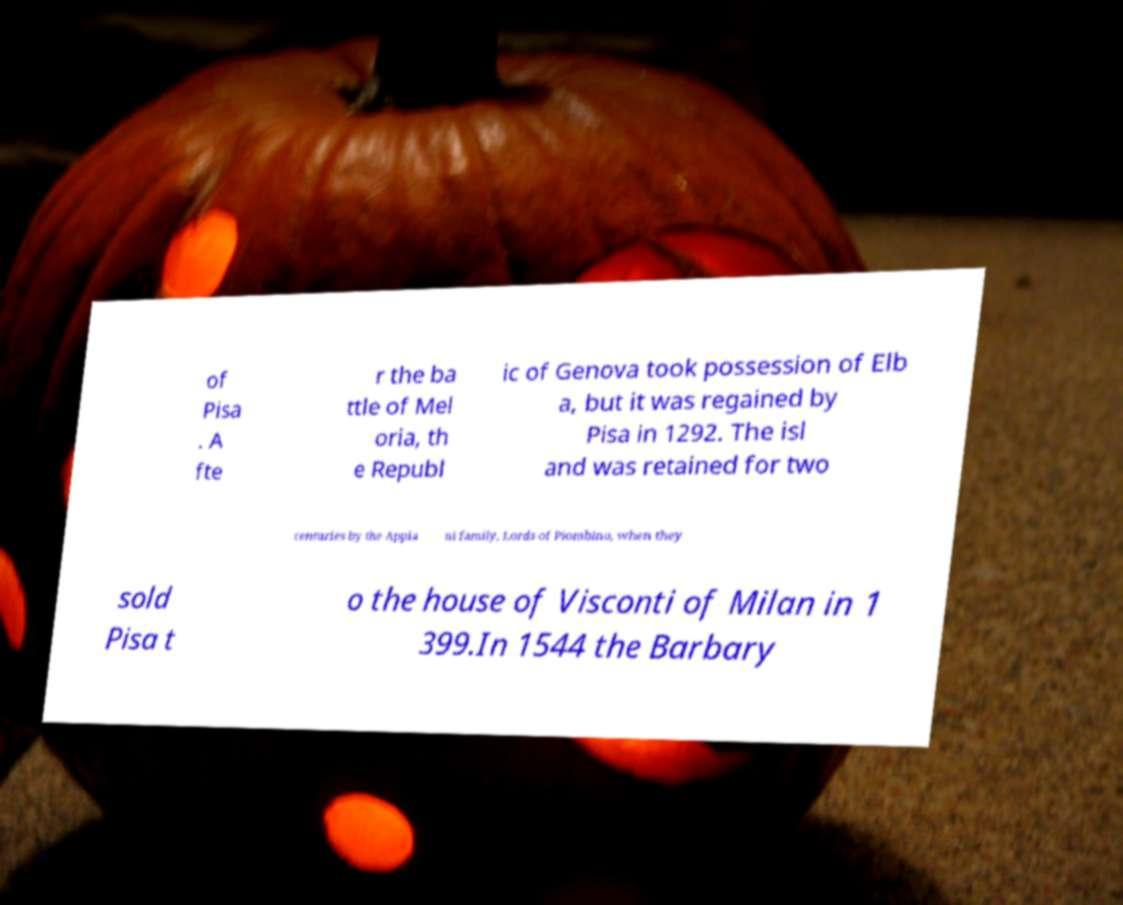I need the written content from this picture converted into text. Can you do that? of Pisa . A fte r the ba ttle of Mel oria, th e Republ ic of Genova took possession of Elb a, but it was regained by Pisa in 1292. The isl and was retained for two centuries by the Appia ni family, Lords of Piombino, when they sold Pisa t o the house of Visconti of Milan in 1 399.In 1544 the Barbary 